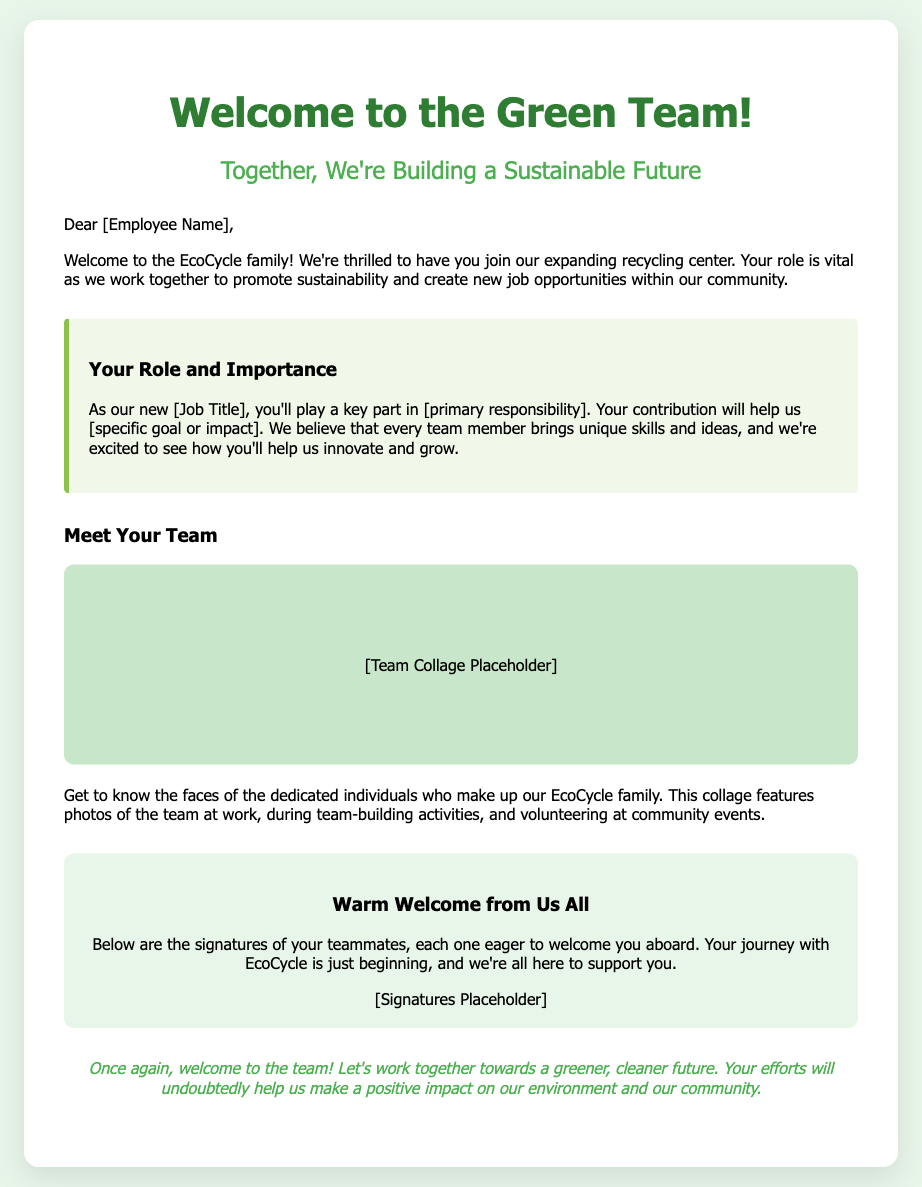What is the name of the team? The document introduces the team as the "EcoCycle family."
Answer: EcoCycle family What is the title of the welcome card? The title of the card is highlighted at the top, it states what the card is about.
Answer: Welcome to the Green Team! What is the job title of the new employee? The document has a placeholder for the new employee's job title that needs to be filled.
Answer: [Job Title] What is the main responsibility mentioned in the welcome card? The document includes a placeholder for the primary responsibility of the new employee.
Answer: [primary responsibility] What color scheme is primarily used in the card? The majority of the design features green shades signifying sustainability.
Answer: Green How does the card describe the team's unity? It describes the team as dedicated individuals working together toward a common goal.
Answer: Together What phrase emphasizes the importance of the new employee's role? The card states "Your role is vital" highlighting significance.
Answer: Your role is vital What does the card aim to promote within the community? The card mentions promoting sustainability and creating job opportunities.
Answer: Sustainability and job opportunities What is depicted in the team collage section? The "team collage" section features images highlighting teamwork and community events.
Answer: Team photos What is the closing sentiment expressed in the card? The closing expresses a positive outlook towards working for a greener future.
Answer: Let's work together towards a greener, cleaner future 